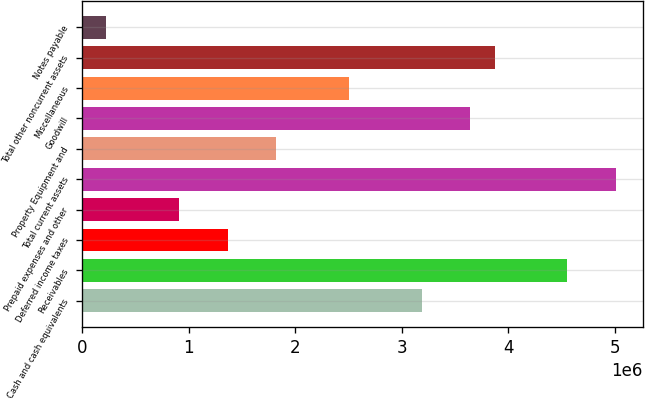<chart> <loc_0><loc_0><loc_500><loc_500><bar_chart><fcel>Cash and cash equivalents<fcel>Receivables<fcel>Deferred income taxes<fcel>Prepaid expenses and other<fcel>Total current assets<fcel>Property Equipment and<fcel>Goodwill<fcel>Miscellaneous<fcel>Total other noncurrent assets<fcel>Notes payable<nl><fcel>3.18929e+06<fcel>4.5561e+06<fcel>1.36687e+06<fcel>911262<fcel>5.01171e+06<fcel>1.82247e+06<fcel>3.64489e+06<fcel>2.50588e+06<fcel>3.8727e+06<fcel>227854<nl></chart> 